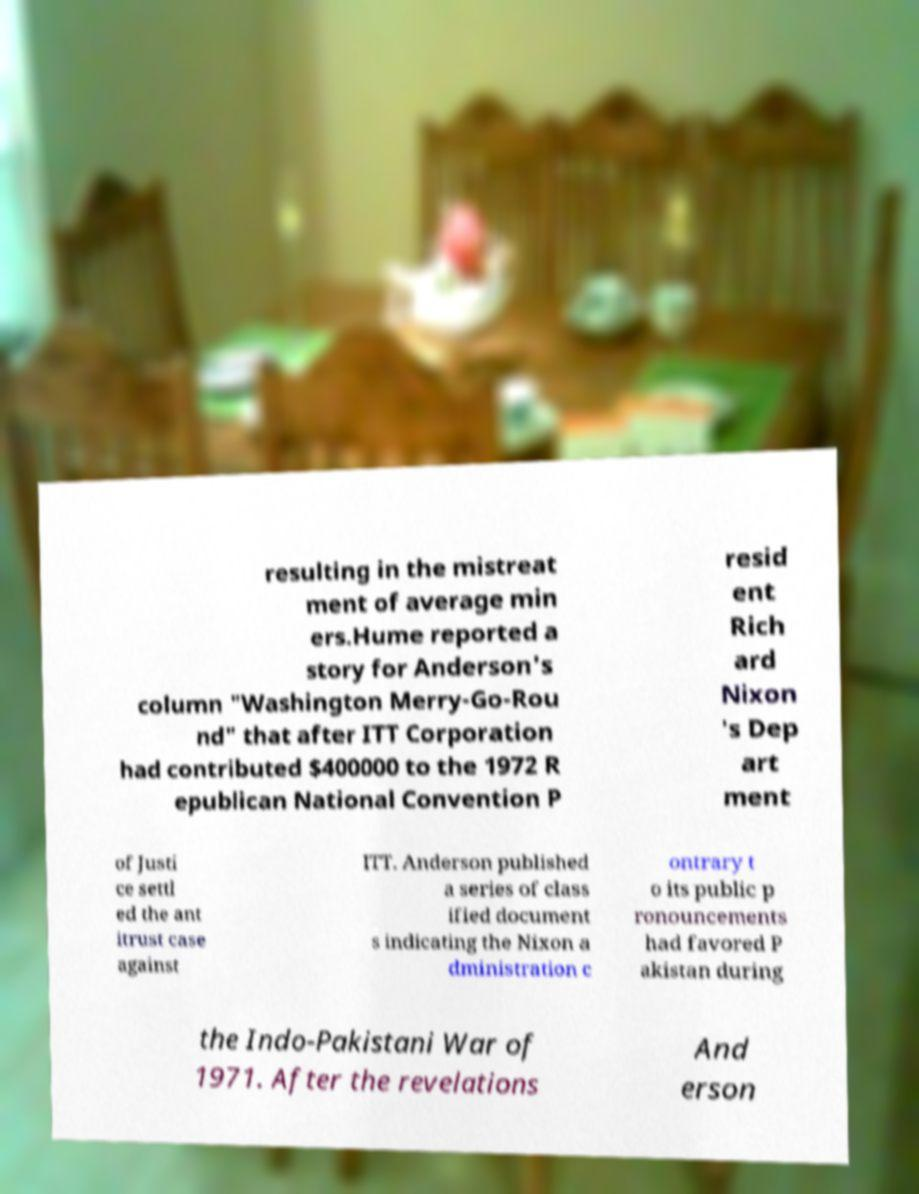Can you accurately transcribe the text from the provided image for me? resulting in the mistreat ment of average min ers.Hume reported a story for Anderson's column "Washington Merry-Go-Rou nd" that after ITT Corporation had contributed $400000 to the 1972 R epublican National Convention P resid ent Rich ard Nixon 's Dep art ment of Justi ce settl ed the ant itrust case against ITT. Anderson published a series of class ified document s indicating the Nixon a dministration c ontrary t o its public p ronouncements had favored P akistan during the Indo-Pakistani War of 1971. After the revelations And erson 